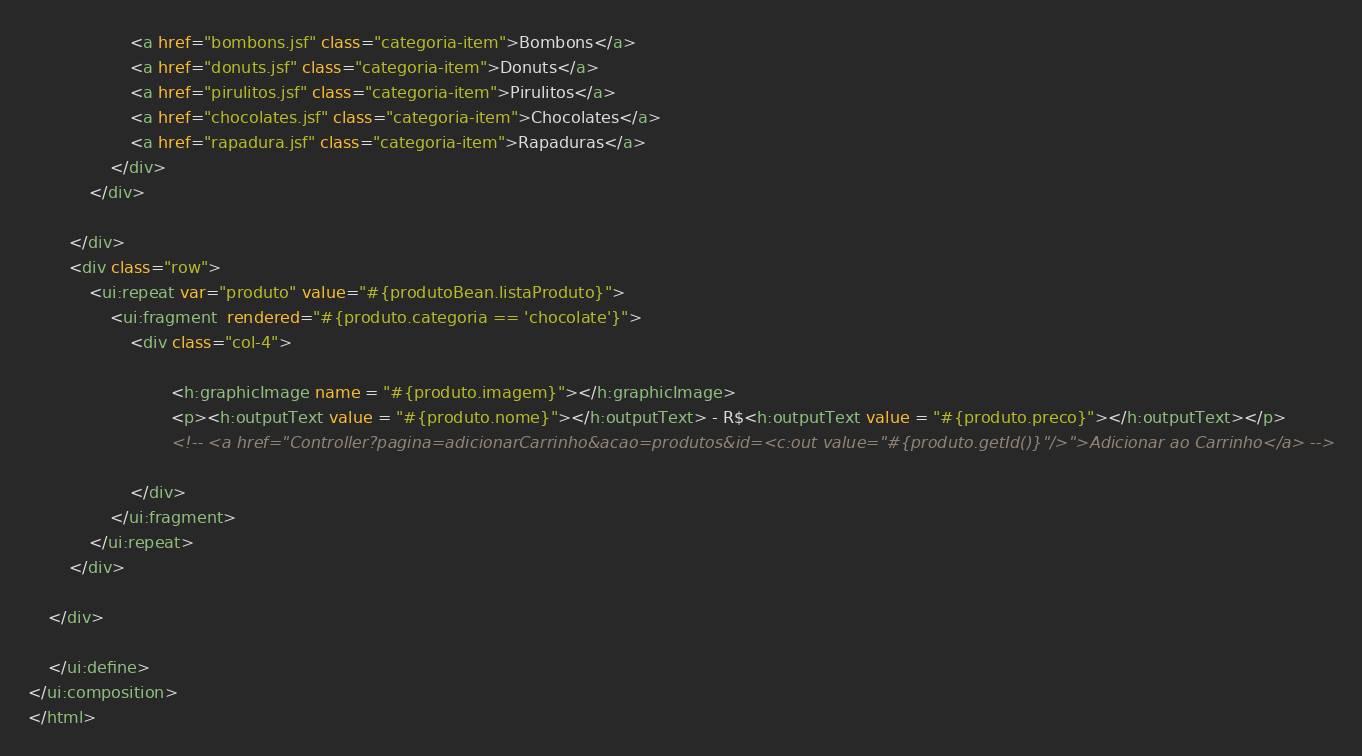<code> <loc_0><loc_0><loc_500><loc_500><_HTML_>					<a href="bombons.jsf" class="categoria-item">Bombons</a>
					<a href="donuts.jsf" class="categoria-item">Donuts</a>
					<a href="pirulitos.jsf" class="categoria-item">Pirulitos</a>
					<a href="chocolates.jsf" class="categoria-item">Chocolates</a>
					<a href="rapadura.jsf" class="categoria-item">Rapaduras</a>
				</div>
			</div>

		</div>
		<div class="row">
			<ui:repeat var="produto" value="#{produtoBean.listaProduto}">
				<ui:fragment  rendered="#{produto.categoria == 'chocolate'}">
					<div class="col-4">
						 
						    <h:graphicImage name = "#{produto.imagem}"></h:graphicImage>
							<p><h:outputText value = "#{produto.nome}"></h:outputText> - R$<h:outputText value = "#{produto.preco}"></h:outputText></p>
							<!-- <a href="Controller?pagina=adicionarCarrinho&acao=produtos&id=<c:out value="#{produto.getId()}"/>">Adicionar ao Carrinho</a> -->
						
					</div>
				</ui:fragment>
			</ui:repeat>
		</div>
	
	</div>
	
	</ui:define>
</ui:composition>
</html>
</code> 